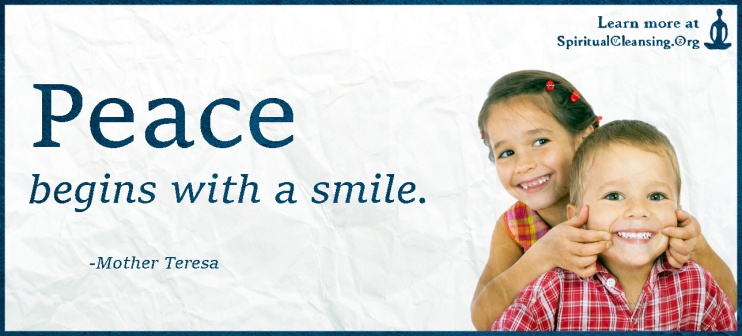What message do you think the designers intended to convey with the use of the crumpled paper texture in the background? The crumpled paper texture in the background might be deliberately chosen to convey a sense of authenticity and accessibility. It suggests that the message of peace and positivity is not just for a polished, ideal world but is relevant and attainable in our imperfect, everyday life. This texture adds a tactile, relatable feel to the banner, reinforcing the personal and grassroots nature of beginning peace with a simple act like smiling. 